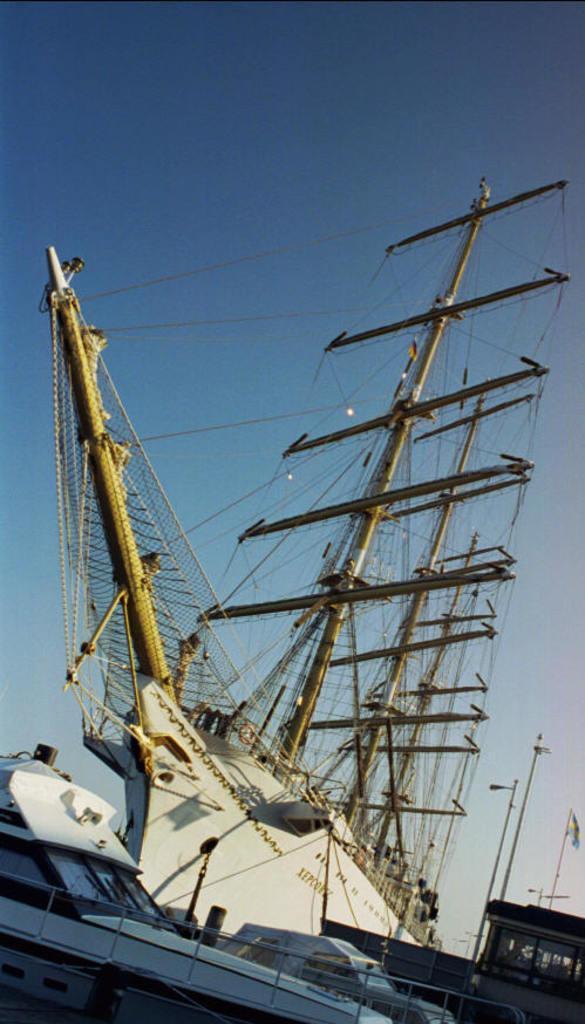In one or two sentences, can you explain what this image depicts? In this picture I can see there is a huge ship and there are yacht into left and the sky is clear. 